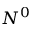<formula> <loc_0><loc_0><loc_500><loc_500>N ^ { 0 }</formula> 